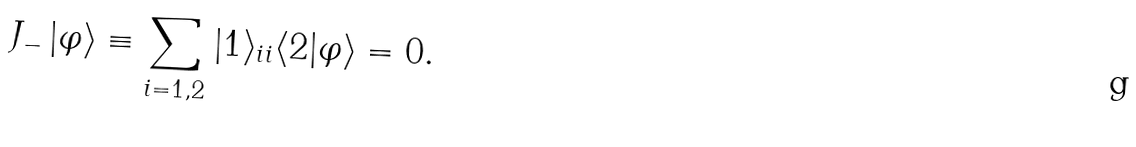Convert formula to latex. <formula><loc_0><loc_0><loc_500><loc_500>J _ { - } \, | \varphi \rangle \equiv \sum _ { i = 1 , 2 } | 1 \rangle _ { i i } \langle 2 | \varphi \rangle = 0 .</formula> 